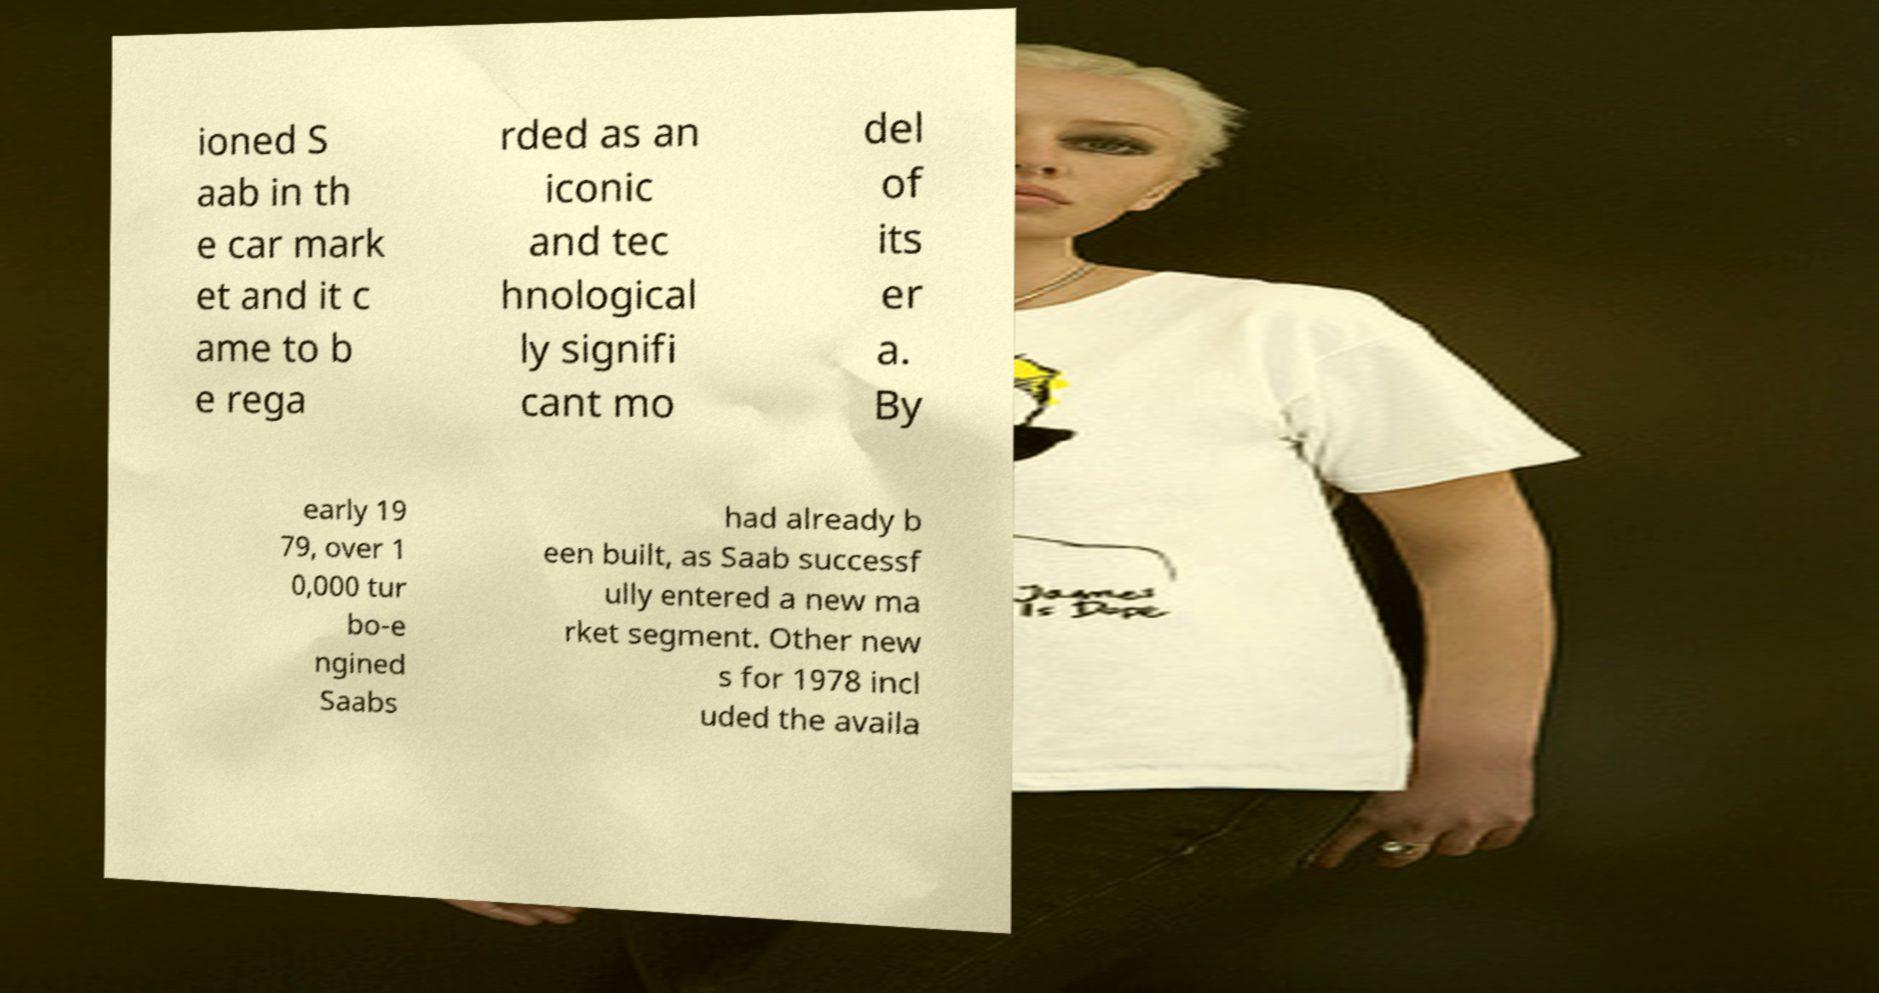For documentation purposes, I need the text within this image transcribed. Could you provide that? ioned S aab in th e car mark et and it c ame to b e rega rded as an iconic and tec hnological ly signifi cant mo del of its er a. By early 19 79, over 1 0,000 tur bo-e ngined Saabs had already b een built, as Saab successf ully entered a new ma rket segment. Other new s for 1978 incl uded the availa 